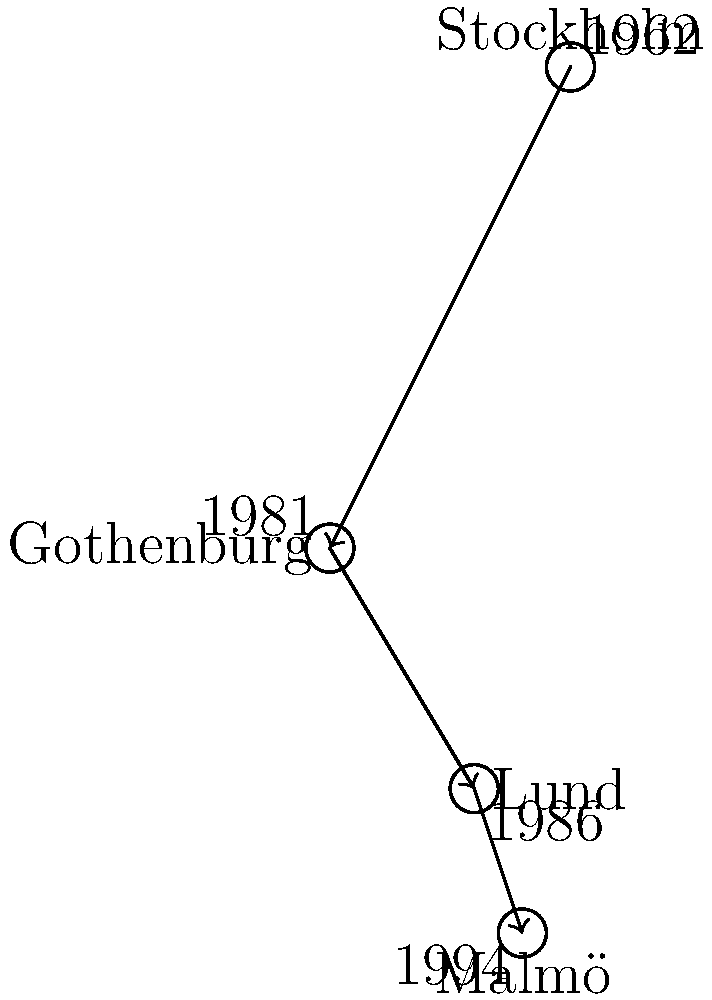Based on the map showing Helge Brinkeback's major life events, what was the chronological order of cities he lived in, starting from his birthplace? To answer this question, we need to analyze the map and the timeline provided:

1. The map shows four cities in Sweden: Stockholm, Gothenburg, Lund, and Malmö.
2. Each city is associated with a year, indicating a significant event in Helge Brinkeback's life.
3. The arrows on the map suggest the direction of movement between cities.
4. The chronological order can be determined by following the years:

   - Stockholm (1962): This is likely Brinkeback's birthplace, as it's the earliest date.
   - Gothenburg (1981): The next city in the sequence.
   - Lund (1986): Follows Gothenburg chronologically.
   - Malmö (1994): The final city in the sequence.

5. The arrows on the map confirm this chronological order, showing movement from Stockholm to Gothenburg, then to Lund, and finally to Malmö.

Therefore, the chronological order of cities Helge Brinkeback lived in, starting from his birthplace, is Stockholm, Gothenburg, Lund, and Malmö.
Answer: Stockholm, Gothenburg, Lund, Malmö 